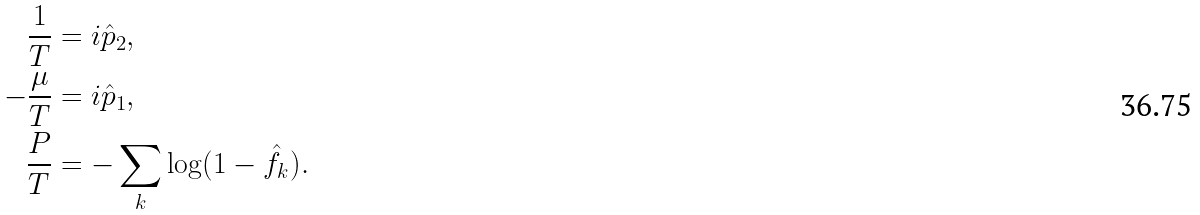Convert formula to latex. <formula><loc_0><loc_0><loc_500><loc_500>\frac { 1 } { T } & = i \hat { p } _ { 2 } , \\ - \frac { \mu } { T } & = i \hat { p } _ { 1 } , \\ \frac { P } { T } & = - \sum _ { k } \log ( 1 - \hat { f } _ { k } ) .</formula> 